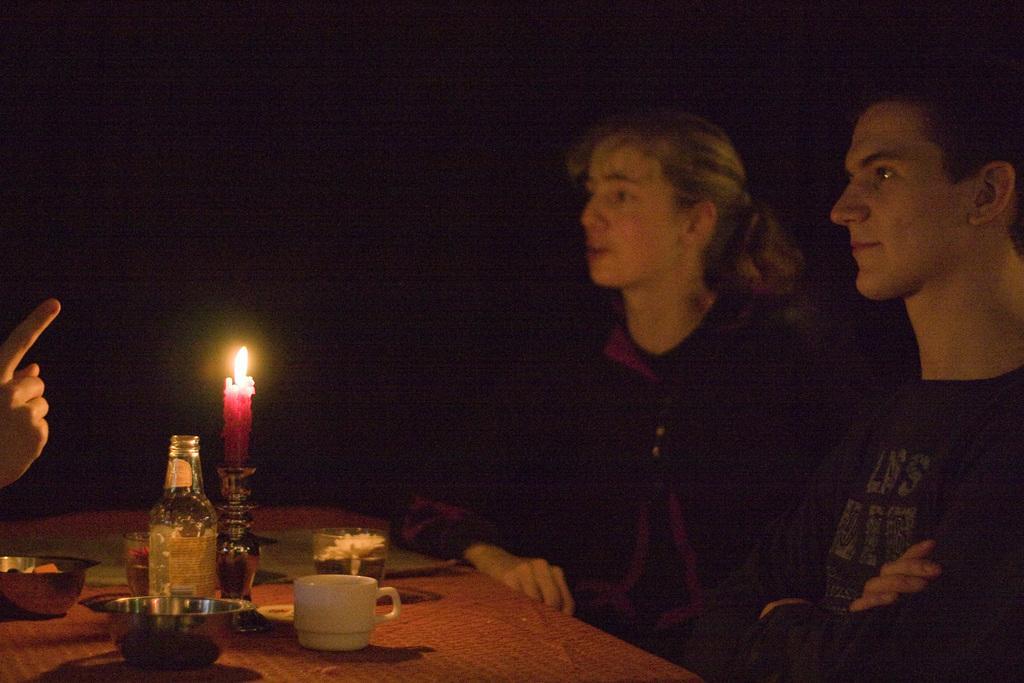In one or two sentences, can you explain what this image depicts? In this image we can see a man and a woman sitting on the chairs and a table is placed in front of them. On the table we can see serving bowls, coffee cup, beverage bottle, candles and a candle holder. 